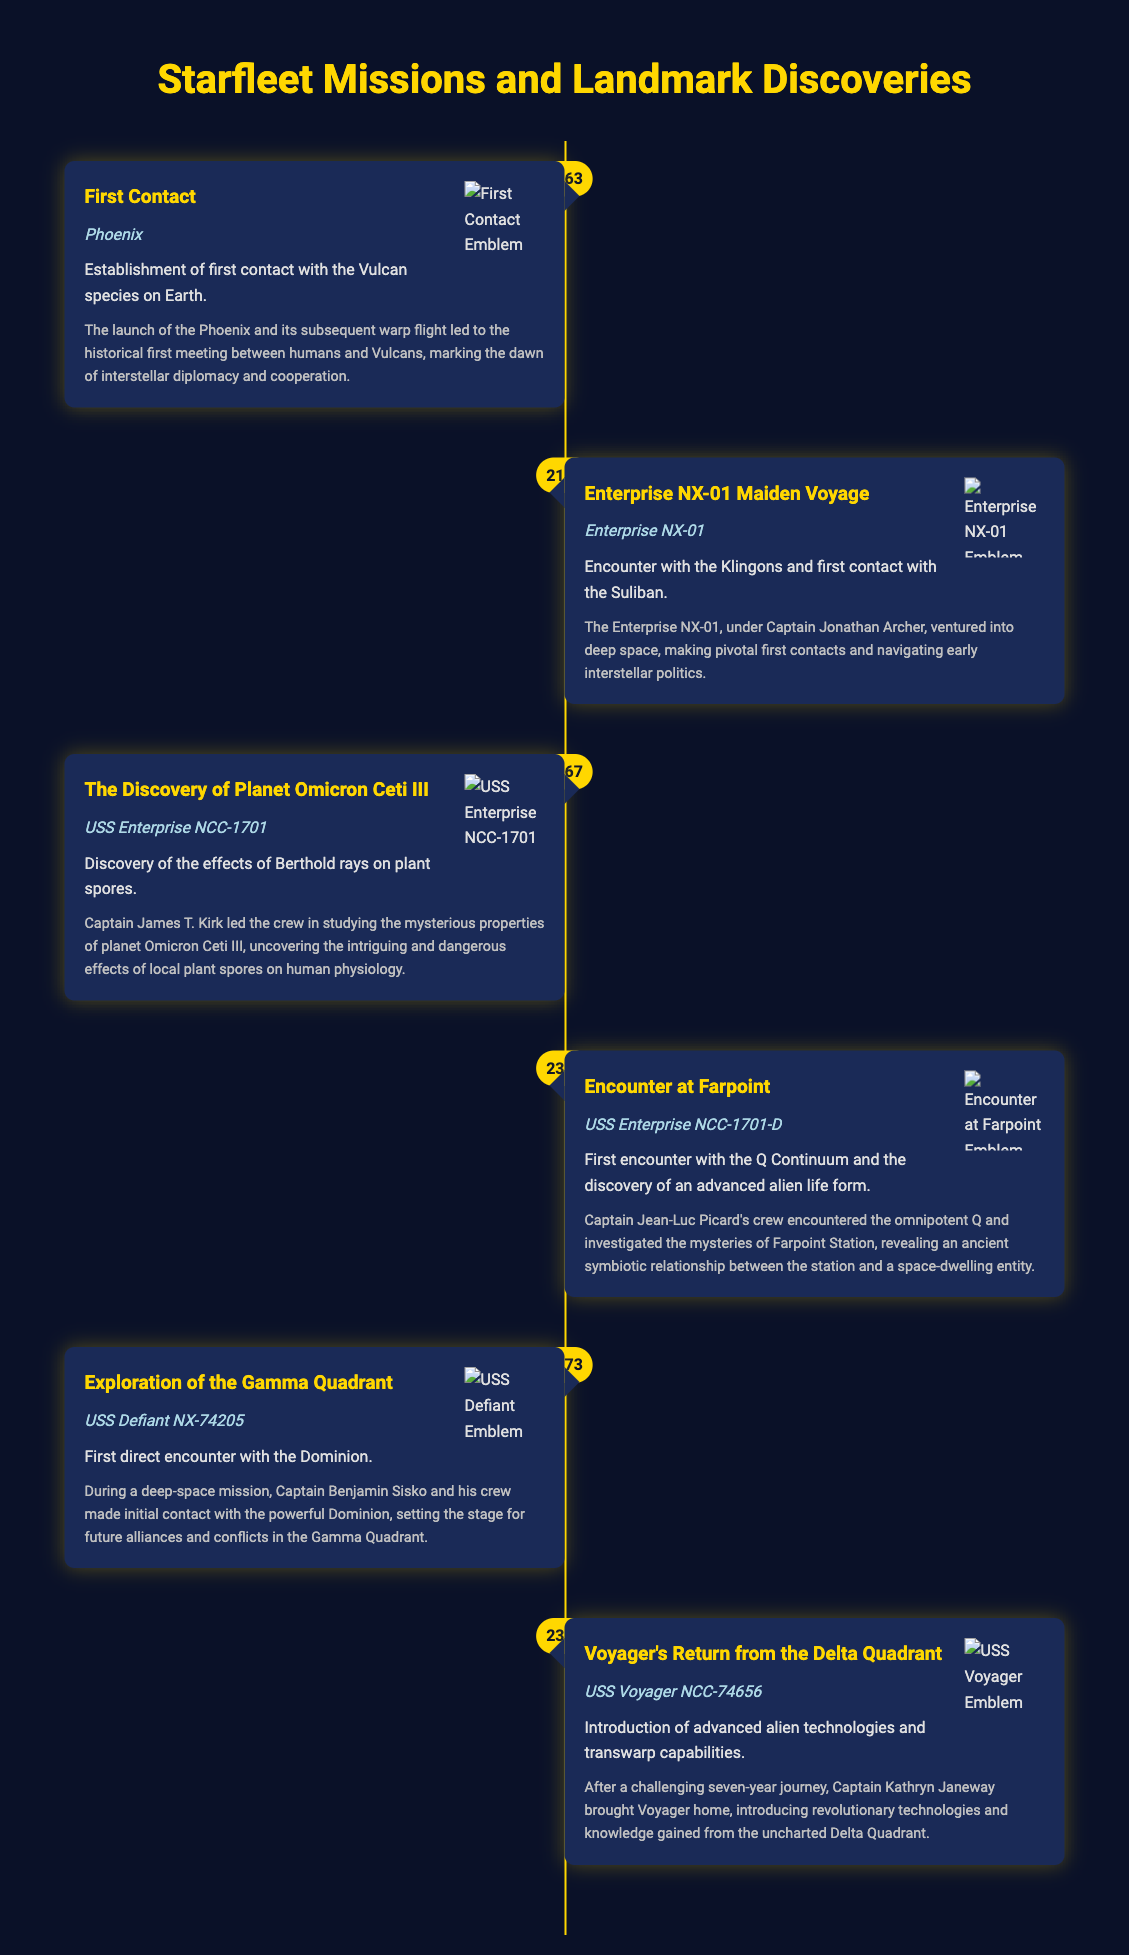What year did the First Contact occur? The document specifies that the First Contact happened in 2063, as indicated in the timeline.
Answer: 2063 What was the name of the starship in the Enterprise NX-01 Maiden Voyage? The starship associated with the Enterprise NX-01 Maiden Voyage is called Enterprise NX-01, according to the timeline.
Answer: Enterprise NX-01 What life form was first encountered during the Encounter at Farpoint mission? The mission details indicate that the first encounter with the Q Continuum involved discovering an advanced alien life form at Farpoint.
Answer: Q Continuum How many years did Voyager spend in the Delta Quadrant? The document states that Voyager spent seven years in the Delta Quadrant before returning home, as mentioned in the summary for Voyager's Return.
Answer: Seven years Which mission involved the discovery of Berthold rays and plant spores? The timeline indicates that the discovery of Berthold rays on planet Omicron Ceti III was part of The Discovery mission.
Answer: The Discovery of Planet Omicron Ceti III In what year was the discovery of the Dominion made? According to the timeline, the first direct encounter with the Dominion occurred in the year 2373.
Answer: 2373 